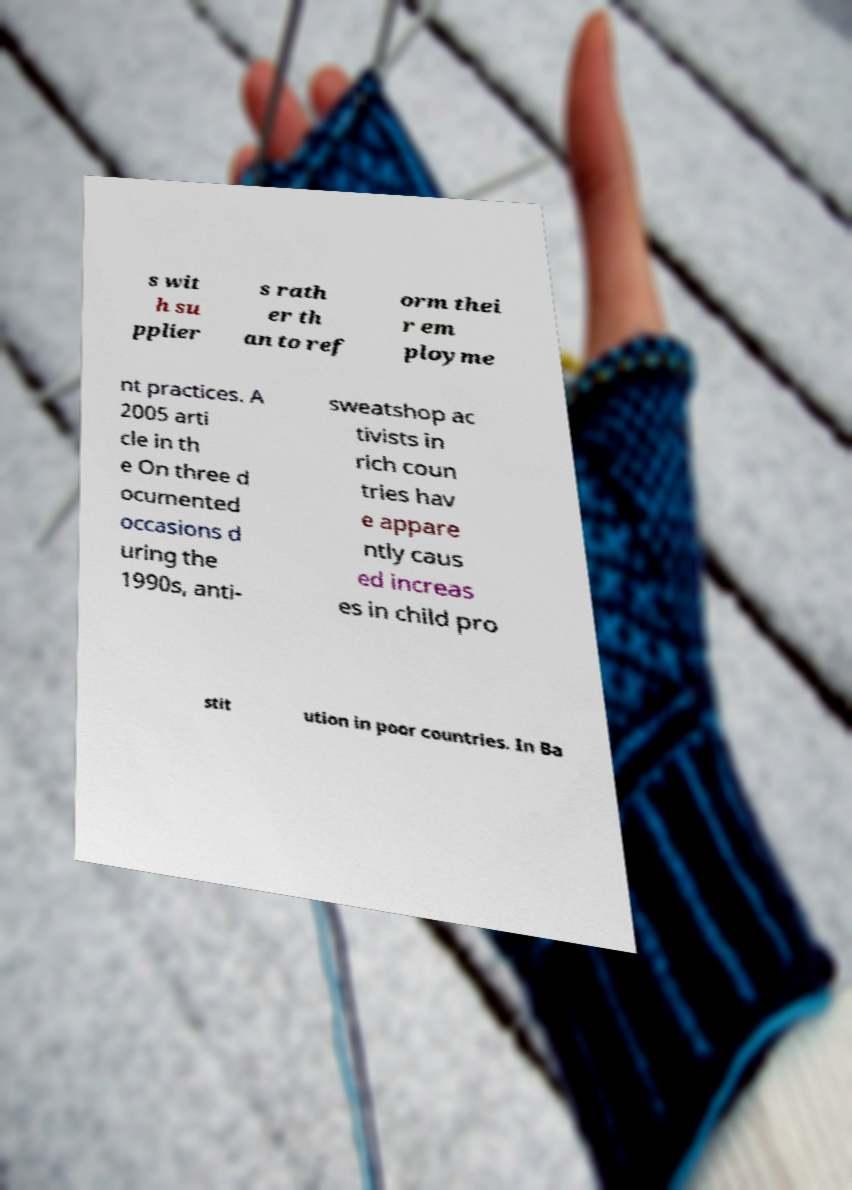For documentation purposes, I need the text within this image transcribed. Could you provide that? s wit h su pplier s rath er th an to ref orm thei r em ployme nt practices. A 2005 arti cle in th e On three d ocumented occasions d uring the 1990s, anti- sweatshop ac tivists in rich coun tries hav e appare ntly caus ed increas es in child pro stit ution in poor countries. In Ba 